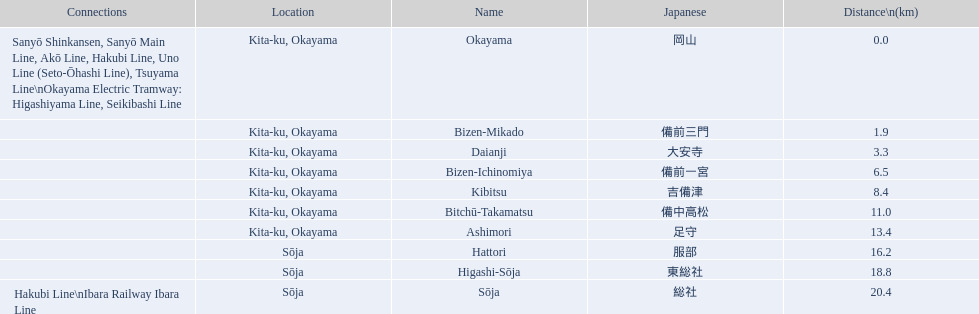What are the members of the kibi line? Okayama, Bizen-Mikado, Daianji, Bizen-Ichinomiya, Kibitsu, Bitchū-Takamatsu, Ashimori, Hattori, Higashi-Sōja, Sōja. Which of them have a distance of more than 1 km? Bizen-Mikado, Daianji, Bizen-Ichinomiya, Kibitsu, Bitchū-Takamatsu, Ashimori, Hattori, Higashi-Sōja, Sōja. Which of them have a distance of less than 2 km? Okayama, Bizen-Mikado. Which has a distance between 1 km and 2 km? Bizen-Mikado. 